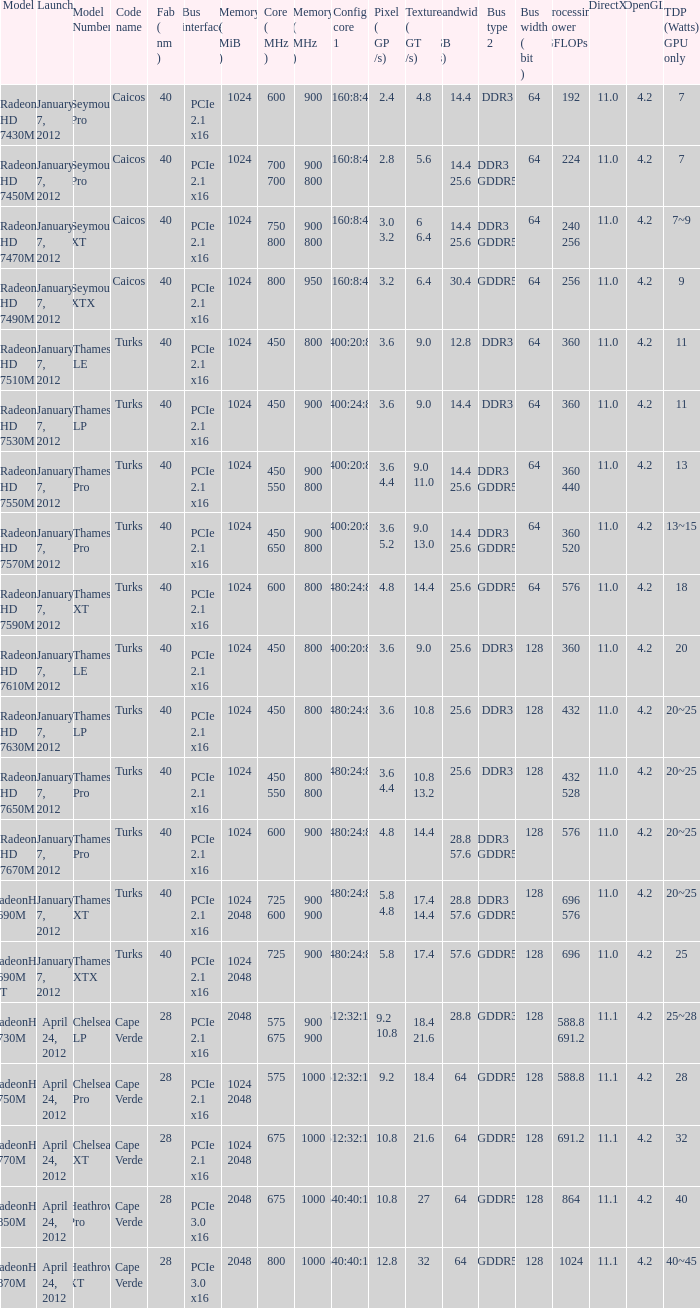What is the config core 1 of the model with a computational capacity of 432 gflops? 480:24:8. 